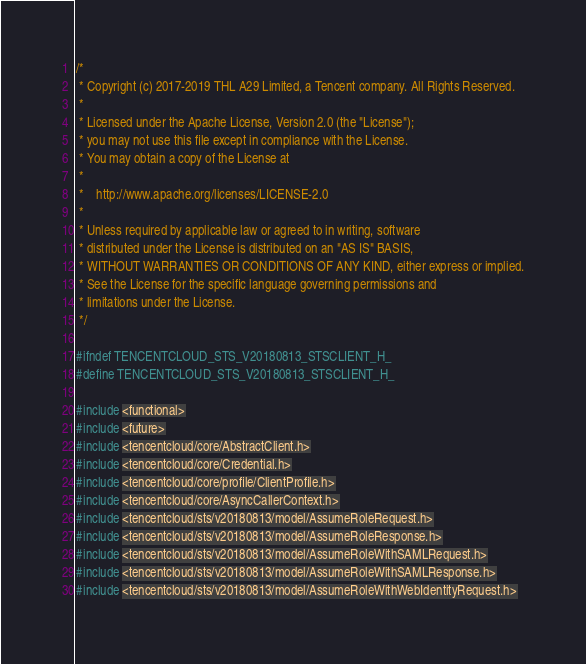Convert code to text. <code><loc_0><loc_0><loc_500><loc_500><_C_>/*
 * Copyright (c) 2017-2019 THL A29 Limited, a Tencent company. All Rights Reserved.
 *
 * Licensed under the Apache License, Version 2.0 (the "License");
 * you may not use this file except in compliance with the License.
 * You may obtain a copy of the License at
 *
 *    http://www.apache.org/licenses/LICENSE-2.0
 *
 * Unless required by applicable law or agreed to in writing, software
 * distributed under the License is distributed on an "AS IS" BASIS,
 * WITHOUT WARRANTIES OR CONDITIONS OF ANY KIND, either express or implied.
 * See the License for the specific language governing permissions and
 * limitations under the License.
 */

#ifndef TENCENTCLOUD_STS_V20180813_STSCLIENT_H_
#define TENCENTCLOUD_STS_V20180813_STSCLIENT_H_

#include <functional>
#include <future>
#include <tencentcloud/core/AbstractClient.h>
#include <tencentcloud/core/Credential.h>
#include <tencentcloud/core/profile/ClientProfile.h>
#include <tencentcloud/core/AsyncCallerContext.h>
#include <tencentcloud/sts/v20180813/model/AssumeRoleRequest.h>
#include <tencentcloud/sts/v20180813/model/AssumeRoleResponse.h>
#include <tencentcloud/sts/v20180813/model/AssumeRoleWithSAMLRequest.h>
#include <tencentcloud/sts/v20180813/model/AssumeRoleWithSAMLResponse.h>
#include <tencentcloud/sts/v20180813/model/AssumeRoleWithWebIdentityRequest.h></code> 